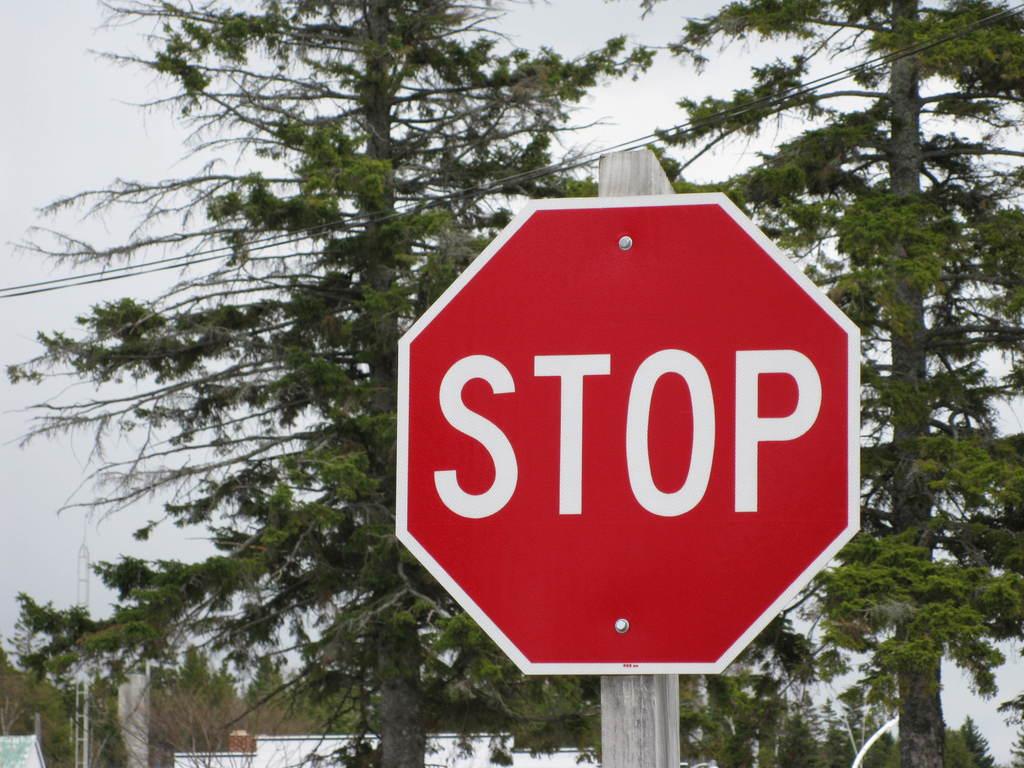What does that stop  sign mean?
Provide a succinct answer. Stop. How many nails are hanging it up?
Your answer should be very brief. Answering does not require reading text in the image. 